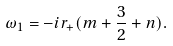Convert formula to latex. <formula><loc_0><loc_0><loc_500><loc_500>\omega _ { 1 } = - i r _ { + } ( m + \frac { 3 } { 2 } + n ) .</formula> 